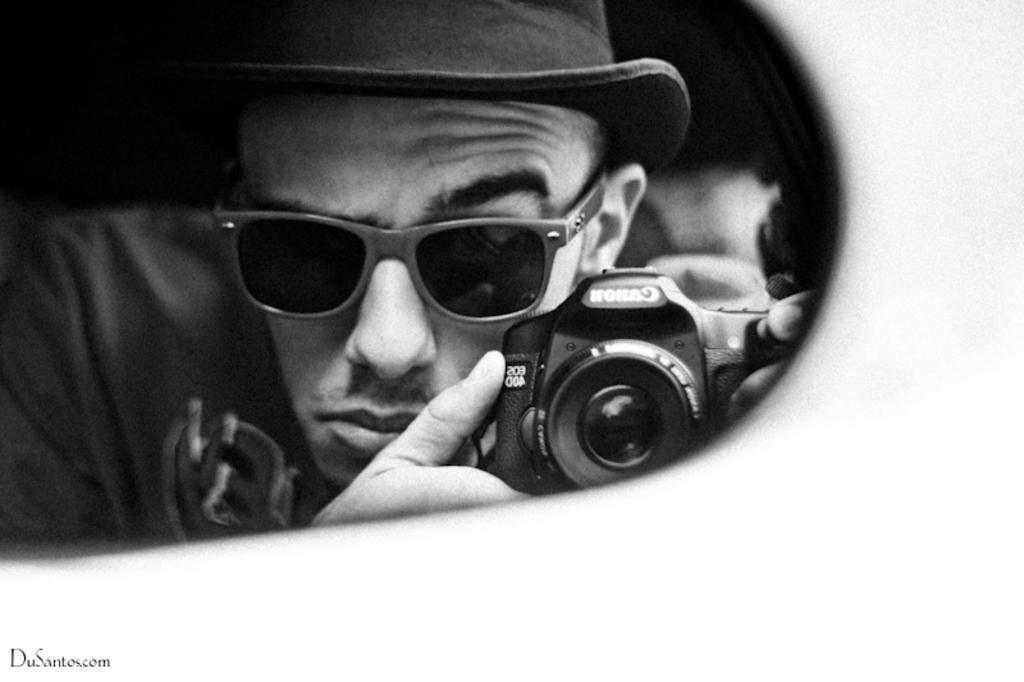Who is the main subject in the image? There is a man in the image. What is the man holding in the image? The man is holding a camera. What brand of camera is the man holding? The camera has "Canon" written on it. What accessories is the man wearing in the image? The man is wearing a shade and a cap. What time does the man watch the hall in the image? There is no mention of a hall or a watch in the image. The man is holding a camera and wearing a shade and a cap. 